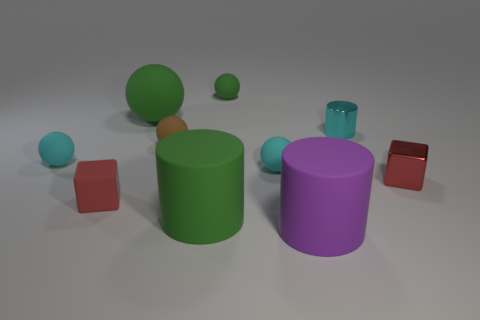Subtract all large matte balls. How many balls are left? 4 Subtract all cyan cylinders. How many cylinders are left? 2 Subtract all cubes. How many objects are left? 8 Subtract all blue cylinders. How many cyan spheres are left? 2 Subtract 1 cylinders. How many cylinders are left? 2 Add 6 large rubber things. How many large rubber things exist? 9 Subtract 1 purple cylinders. How many objects are left? 9 Subtract all yellow cylinders. Subtract all green cubes. How many cylinders are left? 3 Subtract all spheres. Subtract all small metal things. How many objects are left? 3 Add 9 small metal blocks. How many small metal blocks are left? 10 